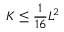Convert formula to latex. <formula><loc_0><loc_0><loc_500><loc_500>K \leq { \frac { 1 } { 1 6 } } L ^ { 2 }</formula> 